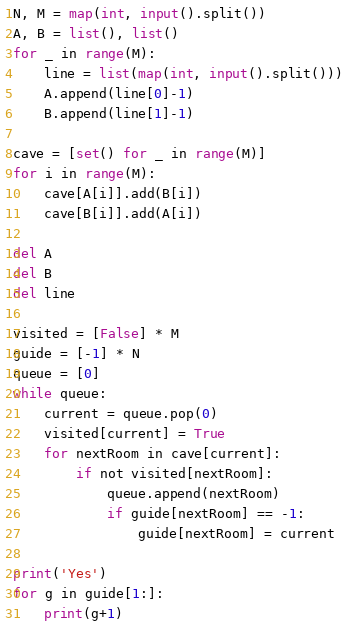Convert code to text. <code><loc_0><loc_0><loc_500><loc_500><_Python_>N, M = map(int, input().split())
A, B = list(), list()
for _ in range(M):
    line = list(map(int, input().split()))
    A.append(line[0]-1)
    B.append(line[1]-1)

cave = [set() for _ in range(M)]
for i in range(M):
    cave[A[i]].add(B[i])
    cave[B[i]].add(A[i])

del A
del B
del line

visited = [False] * M
guide = [-1] * N
queue = [0]
while queue:
    current = queue.pop(0)
    visited[current] = True
    for nextRoom in cave[current]:
        if not visited[nextRoom]:
            queue.append(nextRoom)
            if guide[nextRoom] == -1:
                guide[nextRoom] = current

print('Yes')
for g in guide[1:]:
    print(g+1)
</code> 